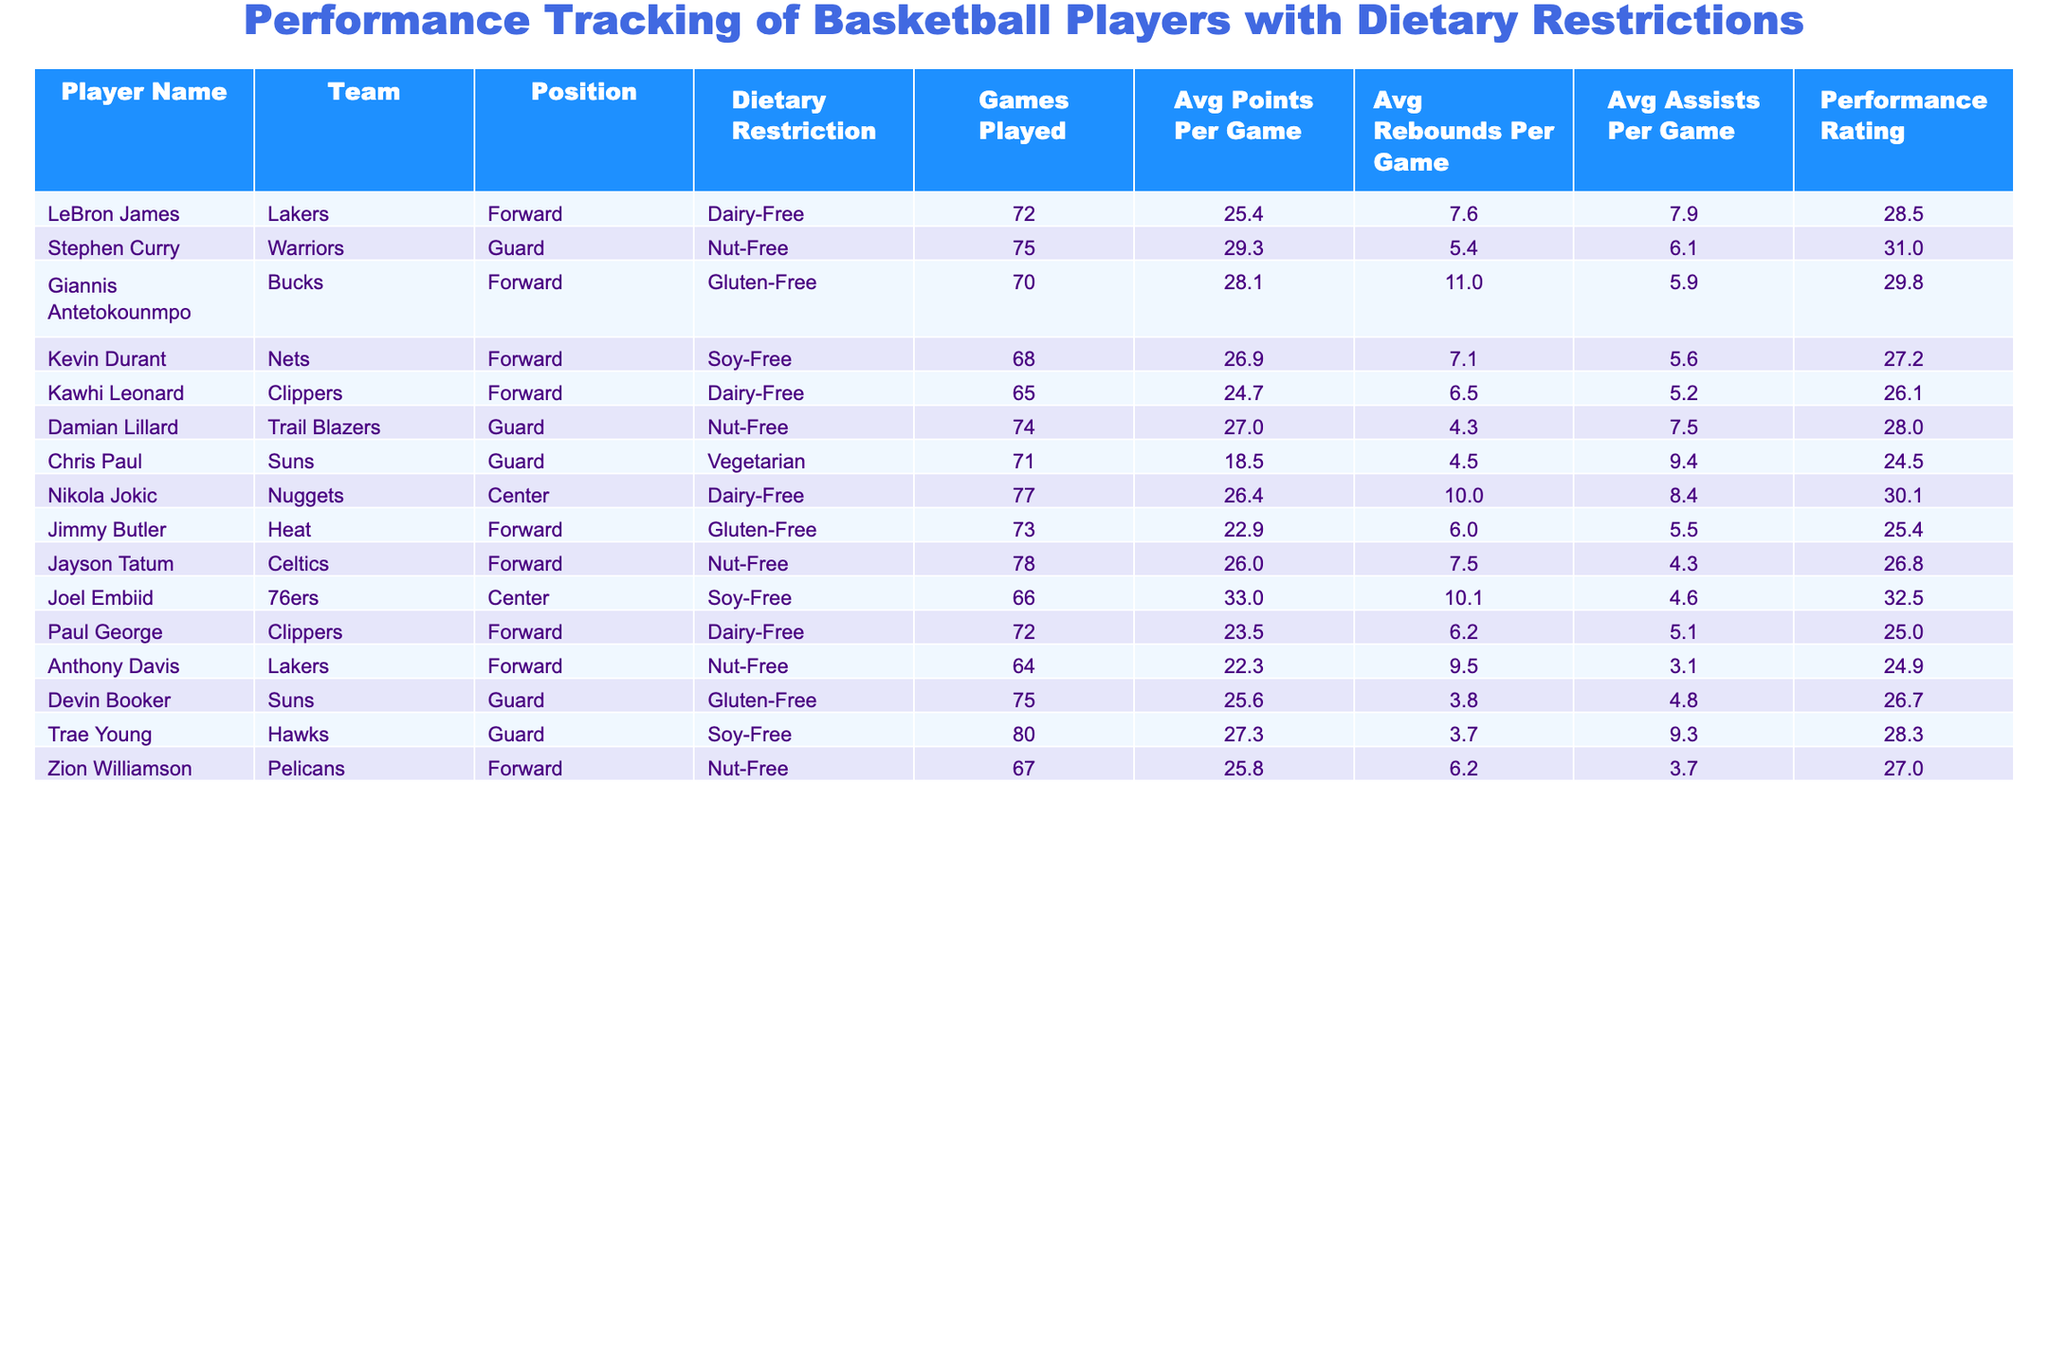What is the average points per game for all players with a nut-free diet? The players with nut-free diets are Stephen Curry, Damian Lillard, Jayson Tatum, and Anthony Davis. Their average points per game are 29.3, 27.0, 26.0, and 22.3, respectively. The sum is (29.3 + 27.0 + 26.0 + 22.3) = 104.6, and there are 4 players, so the average is 104.6 / 4 = 26.15.
Answer: 26.15 Which player has the highest performance rating among those with a gluten-free diet? The players with gluten-free diets are Giannis Antetokounmpo, Jimmy Butler, and Devin Booker. Their performance ratings are 29.8, 25.4, and 26.7, respectively. Giannis Antetokounmpo has the highest rating at 29.8.
Answer: Giannis Antetokounmpo How many games did Kevin Durant play, and how does it compare to the games played by Joel Embiid? Kevin Durant played 68 games, while Joel Embiid played 66 games. The comparison shows that Kevin Durant played 2 more games than Joel Embiid.
Answer: 2 more games What is the total average rebounds per game for all players with dairy-free diets? The players with dairy-free diets are LeBron James, Kawhi Leonard, Nikola Jokic, and Paul George. Their average rebounds per game are 7.6, 6.5, 10.0, and 6.2, respectively. The sum is (7.6 + 6.5 + 10.0 + 6.2) = 30.3. There are 4 players, so the average rebounds per game is 30.3 / 4 = 7.575.
Answer: 7.575 Is there a player with a soy-free diet who has an average points per game less than 25? The players with soy-free diets are Kevin Durant, Joel Embiid, and Trae Young. Their average points are 26.9, 33.0, and 27.3, respectively, which are all above 25. Therefore, no player with a soy-free diet has an average below 25.
Answer: No What is the difference in average performance rating between players with dairy-free and vegetarian diets? The average performance rating for players with dairy-free diets (LeBron James, Kawhi Leonard, Nikola Jokic, and Paul George) is (28.5 + 26.1 + 30.1 + 25.0) / 4 = 27.975. For the vegetarian diet (Chris Paul), the rating is 24.5. The difference is 27.975 - 24.5 = 3.475.
Answer: 3.475 Who is the player with the highest average assists per game, and what is that average? The players with the highest average assists per game are Chris Paul and Trae Young, with 9.4 and 9.3 assists, respectively. Chris Paul has the highest number.
Answer: Chris Paul, 9.4 How does the average rebounds per game of players with a nut-free diet compare to those with a gluten-free diet? For nut-free players (Stephen Curry, Damian Lillard, Jayson Tatum, and Anthony Davis), the average rebounds are (5.4 + 4.3 + 7.5 + 9.5) / 4 = 6.425. For gluten-free players (Giannis Antetokounmpo, Jimmy Butler, Devin Booker), it is (11.0 + 6.0 + 3.8) / 3 = 6.933. The gluten-free players have a higher average of 6.933 - 6.425 = 0.508 more rebounds per game.
Answer: Gluten-free players average 0.508 more rebounds per game 